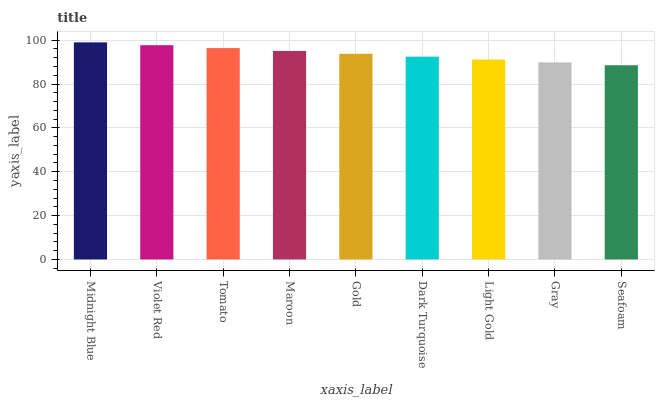Is Seafoam the minimum?
Answer yes or no. Yes. Is Midnight Blue the maximum?
Answer yes or no. Yes. Is Violet Red the minimum?
Answer yes or no. No. Is Violet Red the maximum?
Answer yes or no. No. Is Midnight Blue greater than Violet Red?
Answer yes or no. Yes. Is Violet Red less than Midnight Blue?
Answer yes or no. Yes. Is Violet Red greater than Midnight Blue?
Answer yes or no. No. Is Midnight Blue less than Violet Red?
Answer yes or no. No. Is Gold the high median?
Answer yes or no. Yes. Is Gold the low median?
Answer yes or no. Yes. Is Midnight Blue the high median?
Answer yes or no. No. Is Violet Red the low median?
Answer yes or no. No. 